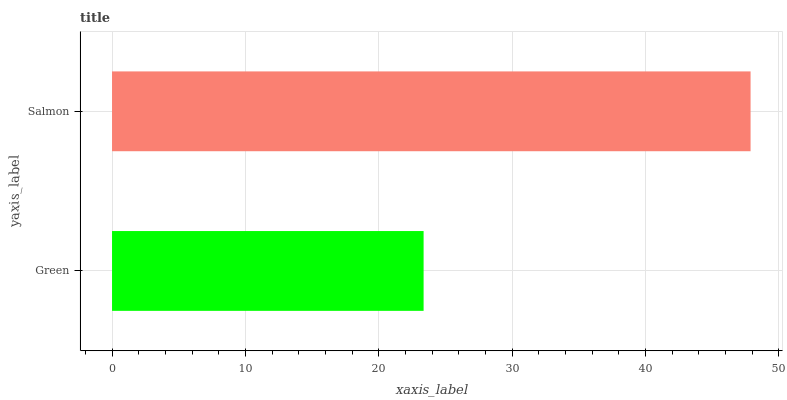Is Green the minimum?
Answer yes or no. Yes. Is Salmon the maximum?
Answer yes or no. Yes. Is Salmon the minimum?
Answer yes or no. No. Is Salmon greater than Green?
Answer yes or no. Yes. Is Green less than Salmon?
Answer yes or no. Yes. Is Green greater than Salmon?
Answer yes or no. No. Is Salmon less than Green?
Answer yes or no. No. Is Salmon the high median?
Answer yes or no. Yes. Is Green the low median?
Answer yes or no. Yes. Is Green the high median?
Answer yes or no. No. Is Salmon the low median?
Answer yes or no. No. 